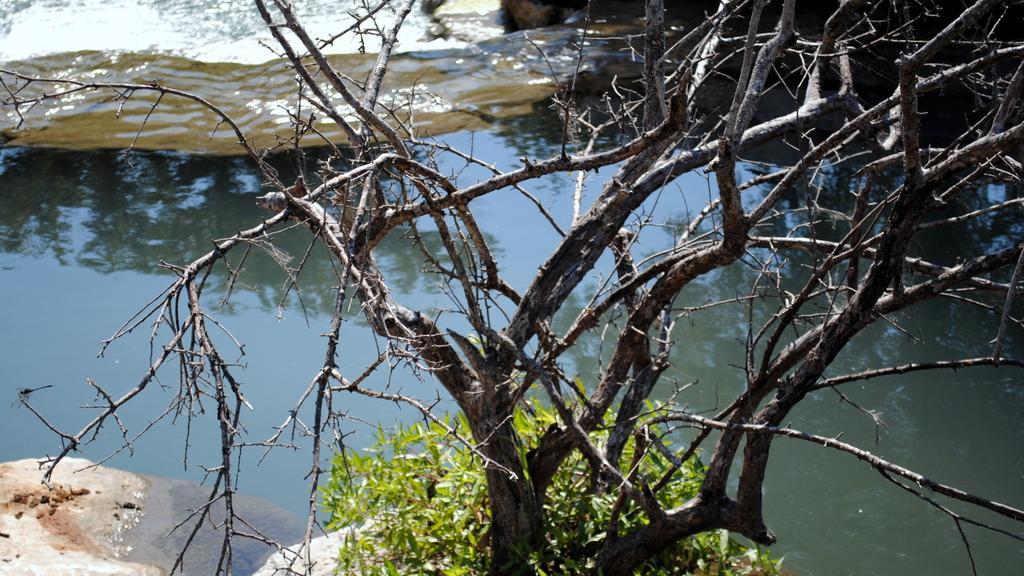Could you give a brief overview of what you see in this image? This image is taken outdoors. At the bottom of the image there is a rock and a tree. In the middle of the image there is a pond with water. At the top of the image there is a rock. 